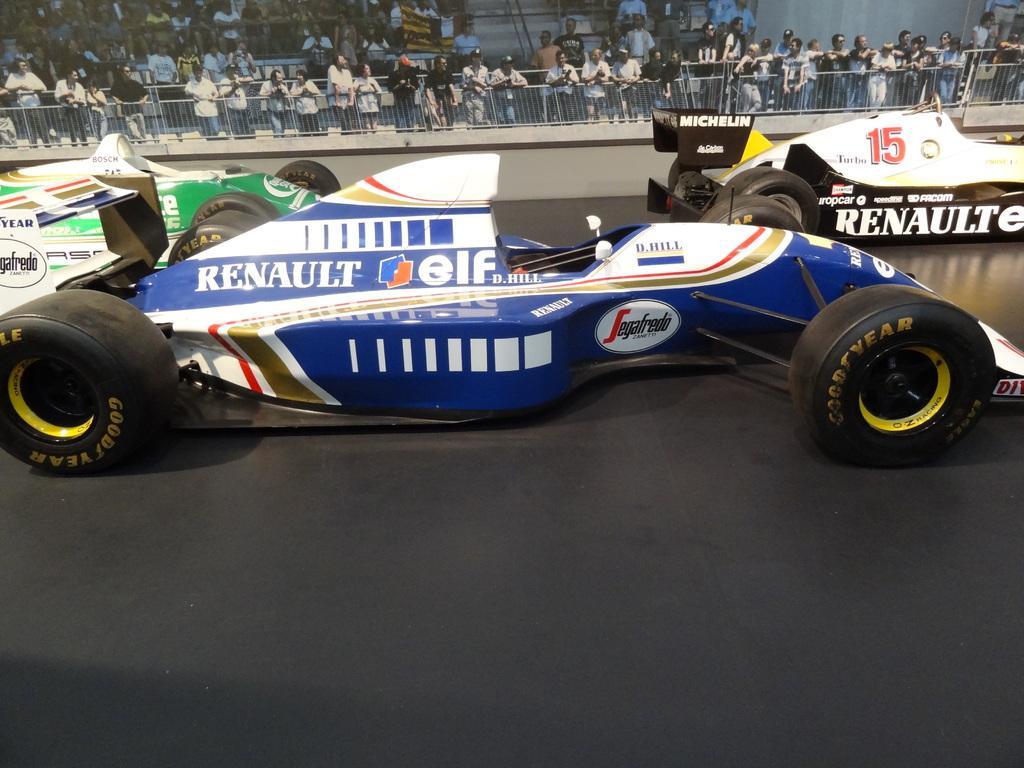How would you summarize this image in a sentence or two? Here we can see vehicles. In the background there is a fence and crowd. 